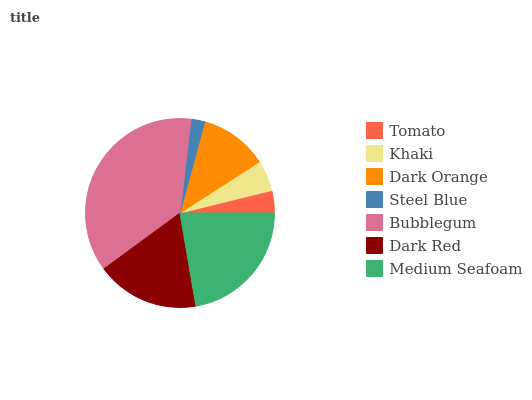Is Steel Blue the minimum?
Answer yes or no. Yes. Is Bubblegum the maximum?
Answer yes or no. Yes. Is Khaki the minimum?
Answer yes or no. No. Is Khaki the maximum?
Answer yes or no. No. Is Khaki greater than Tomato?
Answer yes or no. Yes. Is Tomato less than Khaki?
Answer yes or no. Yes. Is Tomato greater than Khaki?
Answer yes or no. No. Is Khaki less than Tomato?
Answer yes or no. No. Is Dark Orange the high median?
Answer yes or no. Yes. Is Dark Orange the low median?
Answer yes or no. Yes. Is Bubblegum the high median?
Answer yes or no. No. Is Dark Red the low median?
Answer yes or no. No. 